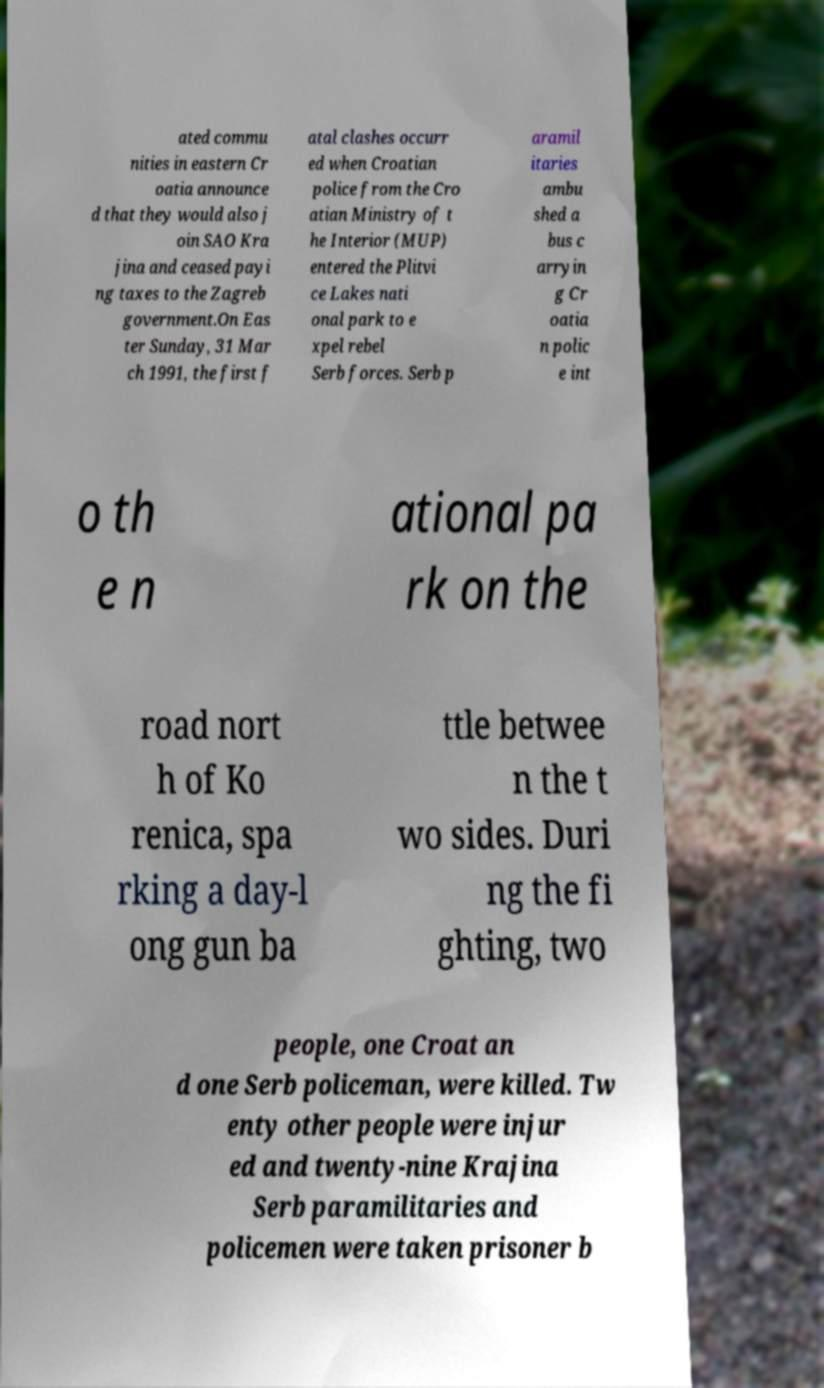Could you assist in decoding the text presented in this image and type it out clearly? ated commu nities in eastern Cr oatia announce d that they would also j oin SAO Kra jina and ceased payi ng taxes to the Zagreb government.On Eas ter Sunday, 31 Mar ch 1991, the first f atal clashes occurr ed when Croatian police from the Cro atian Ministry of t he Interior (MUP) entered the Plitvi ce Lakes nati onal park to e xpel rebel Serb forces. Serb p aramil itaries ambu shed a bus c arryin g Cr oatia n polic e int o th e n ational pa rk on the road nort h of Ko renica, spa rking a day-l ong gun ba ttle betwee n the t wo sides. Duri ng the fi ghting, two people, one Croat an d one Serb policeman, were killed. Tw enty other people were injur ed and twenty-nine Krajina Serb paramilitaries and policemen were taken prisoner b 